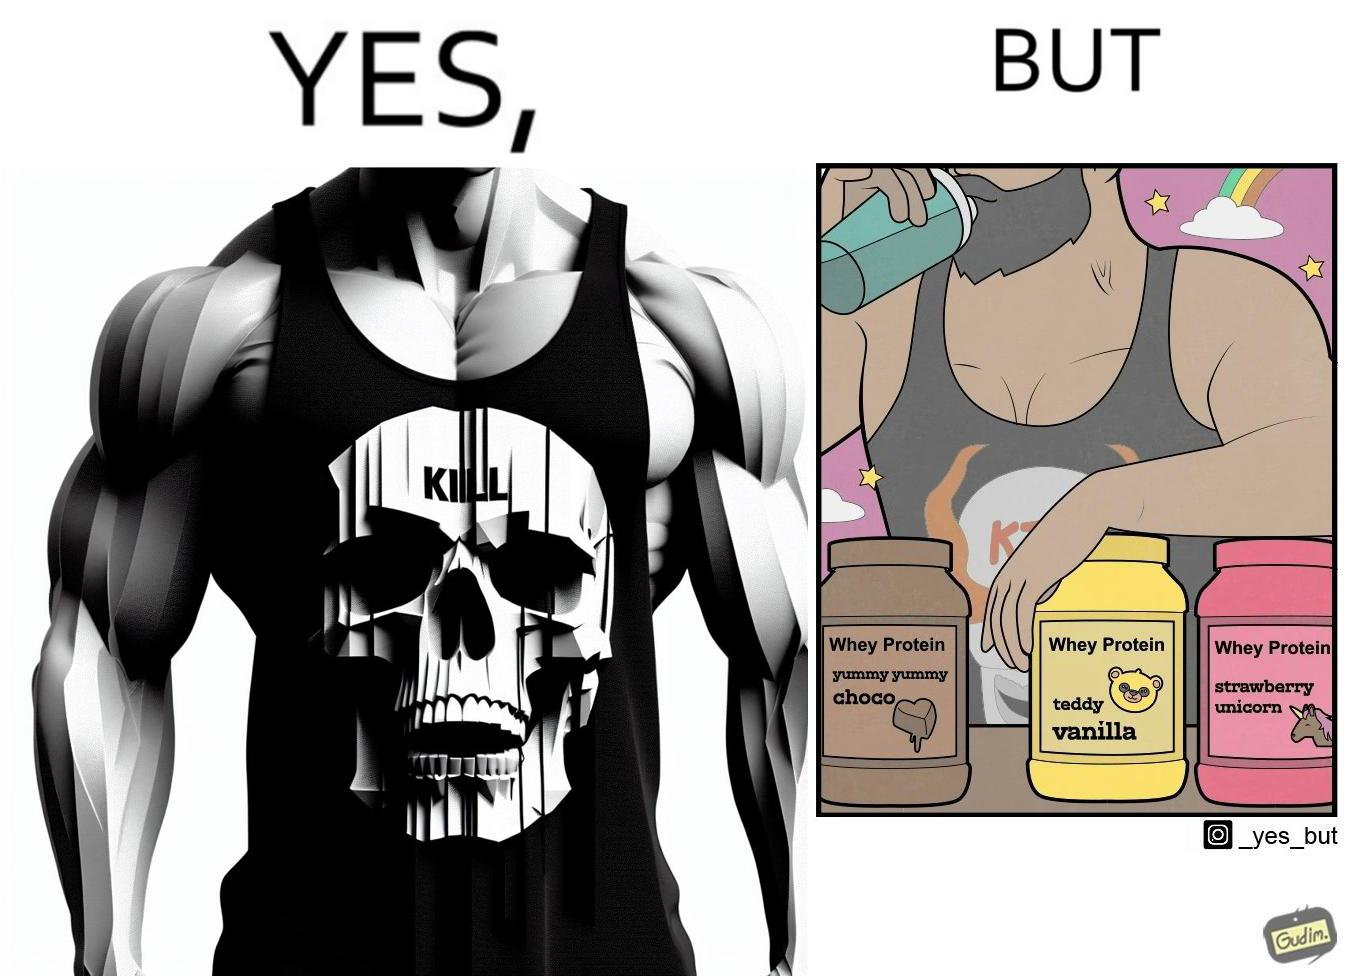Why is this image considered satirical? The image is funny because a well-built person wearing an aggressive tank-top with the word "KILL" on an image of a skull is having very childish flavours of whey protein such as teddy vanilla, yummy yummy choco, and strawberry vanilla, contrary to the person's external persona. This depicts the metaphor 'Do not judge a book by its cover'. 